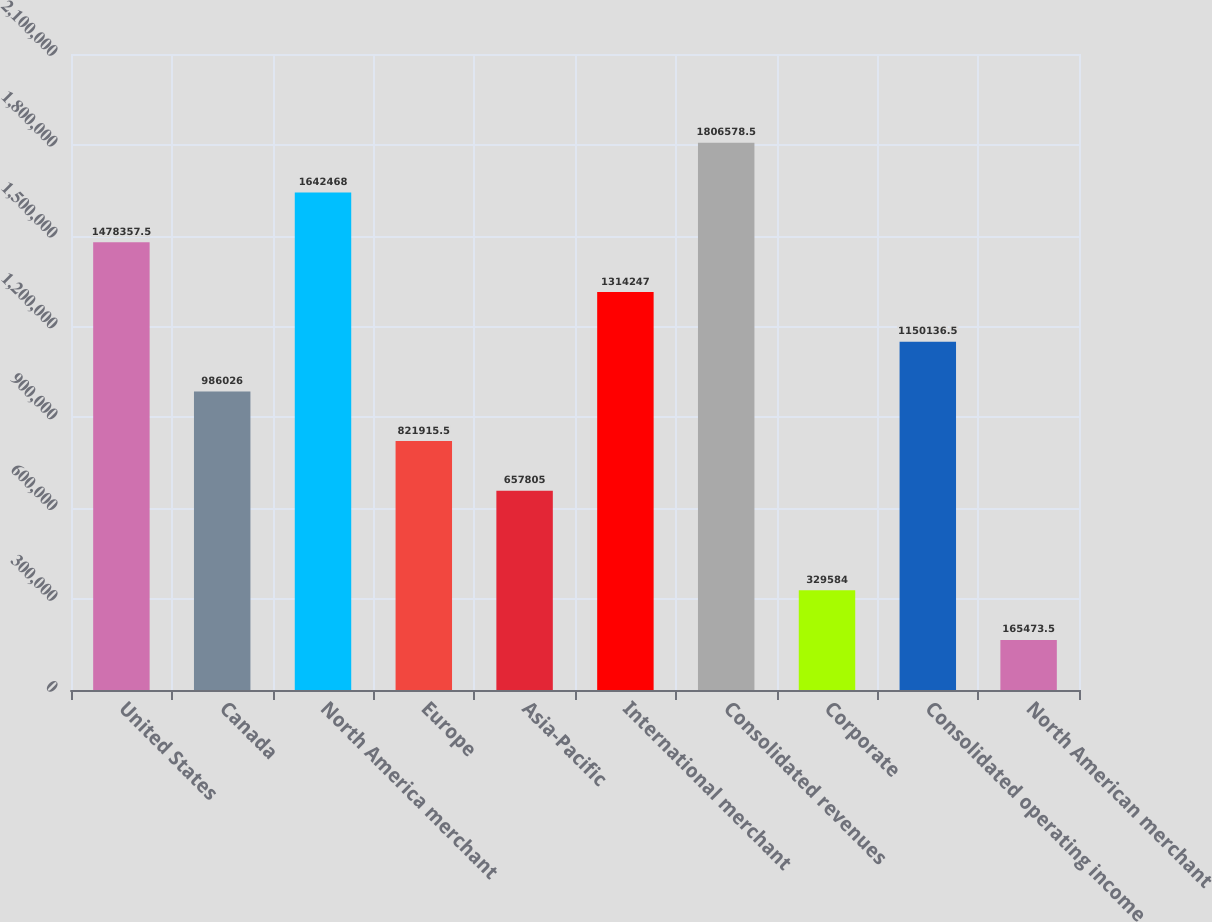Convert chart to OTSL. <chart><loc_0><loc_0><loc_500><loc_500><bar_chart><fcel>United States<fcel>Canada<fcel>North America merchant<fcel>Europe<fcel>Asia-Pacific<fcel>International merchant<fcel>Consolidated revenues<fcel>Corporate<fcel>Consolidated operating income<fcel>North American merchant<nl><fcel>1.47836e+06<fcel>986026<fcel>1.64247e+06<fcel>821916<fcel>657805<fcel>1.31425e+06<fcel>1.80658e+06<fcel>329584<fcel>1.15014e+06<fcel>165474<nl></chart> 